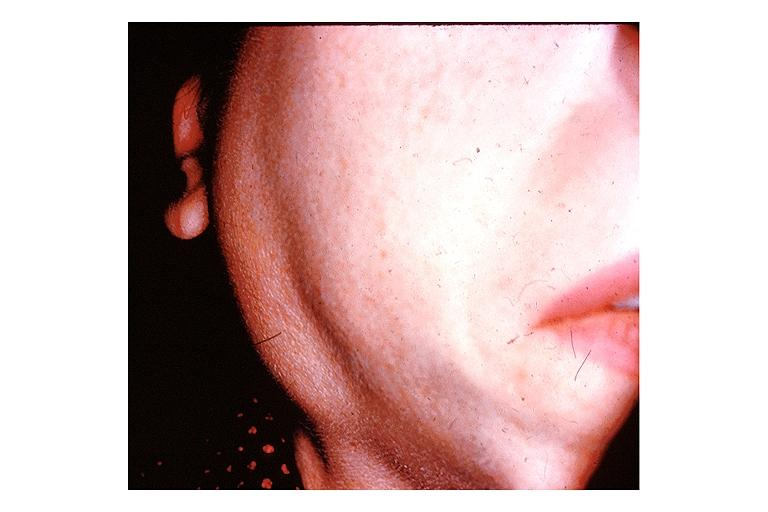what does this image show?
Answer the question using a single word or phrase. Sjogrens syndrome 